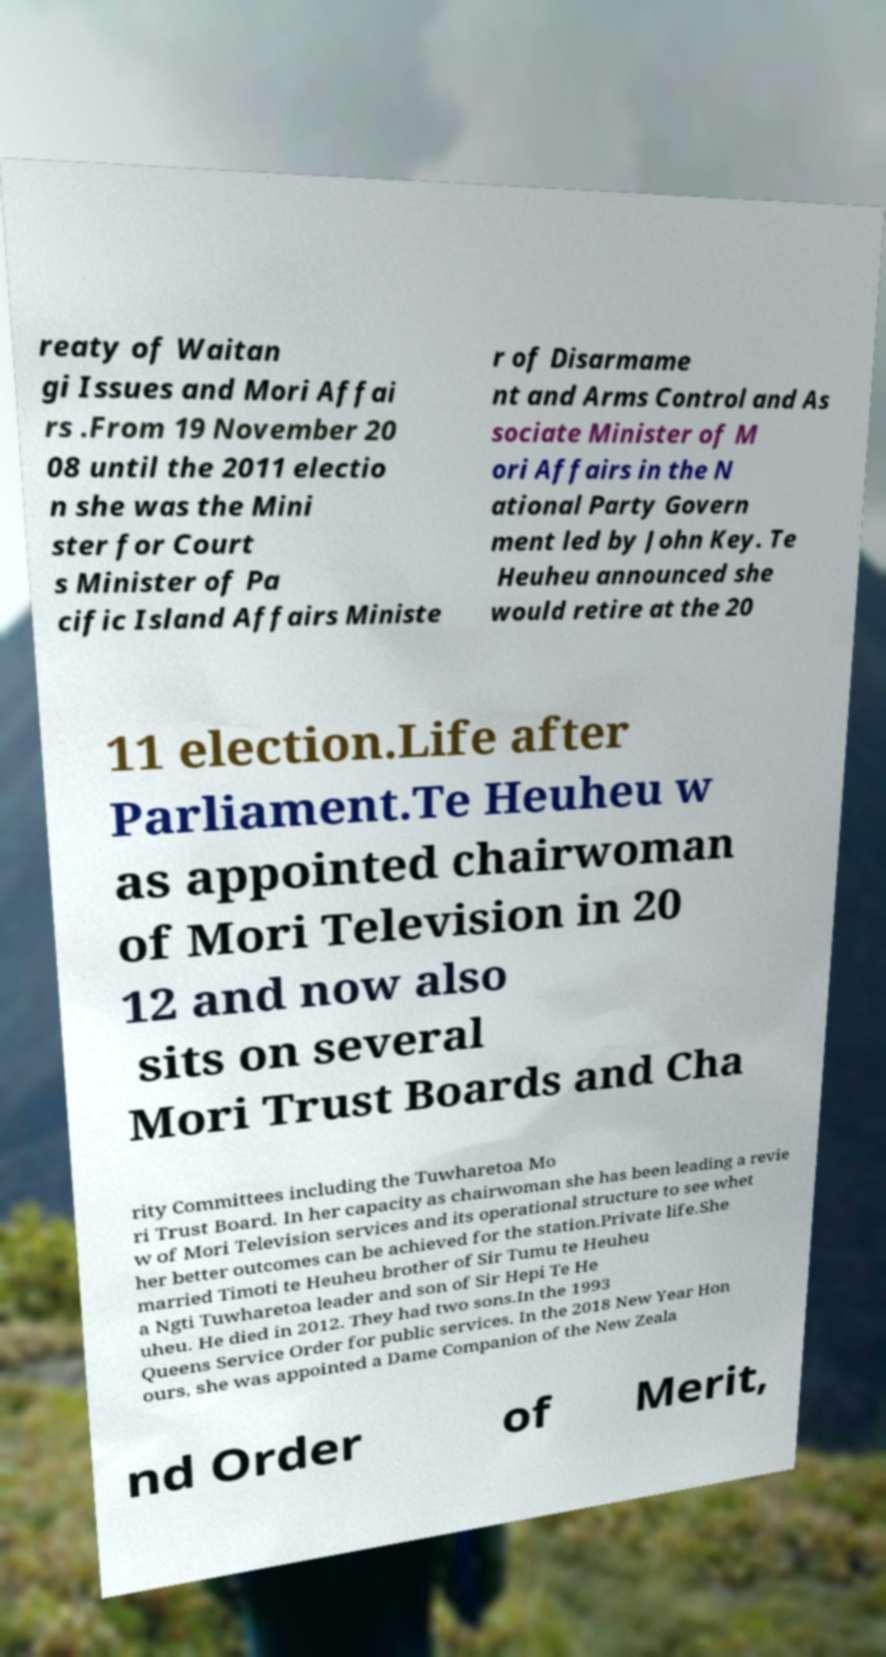Could you extract and type out the text from this image? reaty of Waitan gi Issues and Mori Affai rs .From 19 November 20 08 until the 2011 electio n she was the Mini ster for Court s Minister of Pa cific Island Affairs Ministe r of Disarmame nt and Arms Control and As sociate Minister of M ori Affairs in the N ational Party Govern ment led by John Key. Te Heuheu announced she would retire at the 20 11 election.Life after Parliament.Te Heuheu w as appointed chairwoman of Mori Television in 20 12 and now also sits on several Mori Trust Boards and Cha rity Committees including the Tuwharetoa Mo ri Trust Board. In her capacity as chairwoman she has been leading a revie w of Mori Television services and its operational structure to see whet her better outcomes can be achieved for the station.Private life.She married Timoti te Heuheu brother of Sir Tumu te Heuheu a Ngti Tuwharetoa leader and son of Sir Hepi Te He uheu. He died in 2012. They had two sons.In the 1993 Queens Service Order for public services. In the 2018 New Year Hon ours, she was appointed a Dame Companion of the New Zeala nd Order of Merit, 